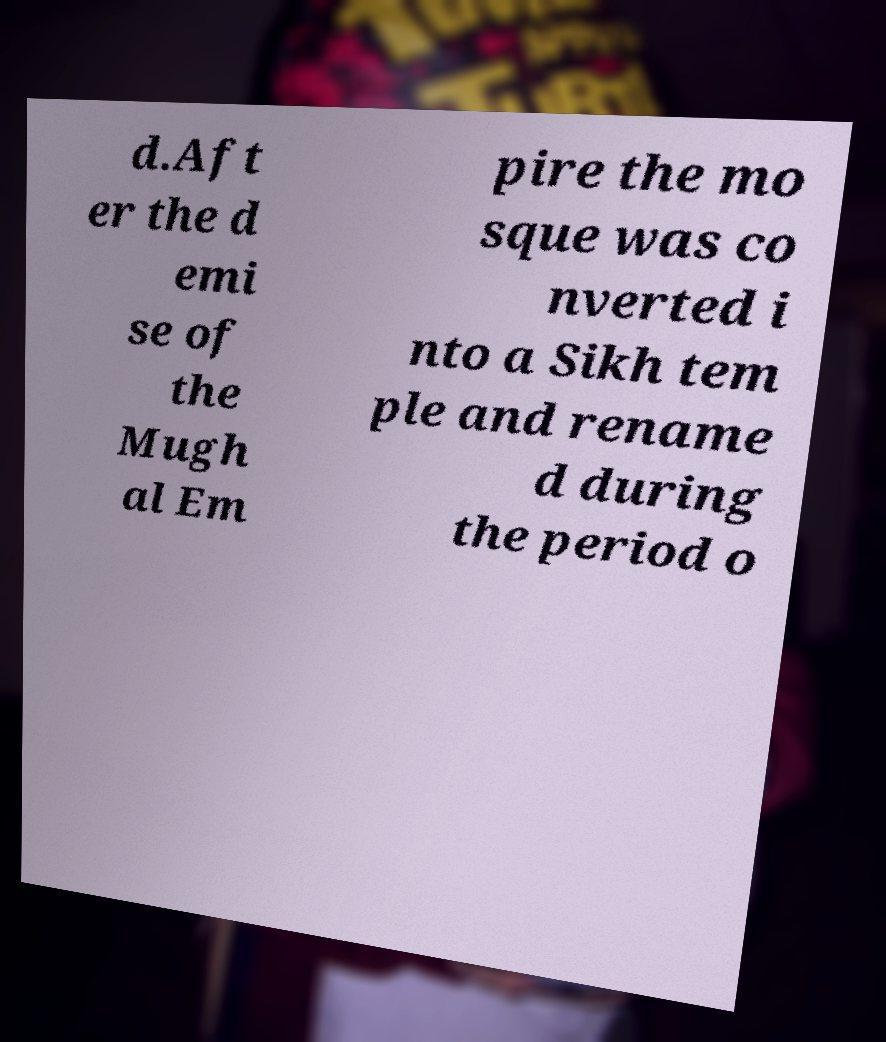Could you assist in decoding the text presented in this image and type it out clearly? d.Aft er the d emi se of the Mugh al Em pire the mo sque was co nverted i nto a Sikh tem ple and rename d during the period o 